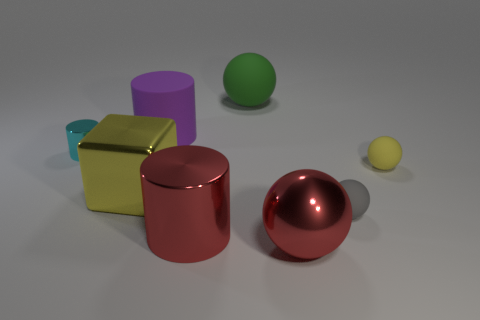Is there any other thing that is the same shape as the big yellow object?
Offer a very short reply. No. How many objects are purple cylinders or matte cylinders that are behind the yellow shiny thing?
Your response must be concise. 1. What material is the yellow sphere?
Offer a very short reply. Rubber. There is a tiny cyan object that is the same shape as the big purple thing; what is its material?
Your response must be concise. Metal. The large metal thing on the right side of the big sphere behind the cyan metallic thing is what color?
Ensure brevity in your answer.  Red. How many matte objects are big brown cylinders or yellow blocks?
Offer a terse response. 0. Does the purple cylinder have the same material as the small gray object?
Provide a short and direct response. Yes. What is the material of the red object that is to the left of the rubber ball that is behind the small yellow matte object?
Make the answer very short. Metal. What number of small things are either blue objects or green spheres?
Ensure brevity in your answer.  0. How big is the cyan metallic object?
Keep it short and to the point. Small. 